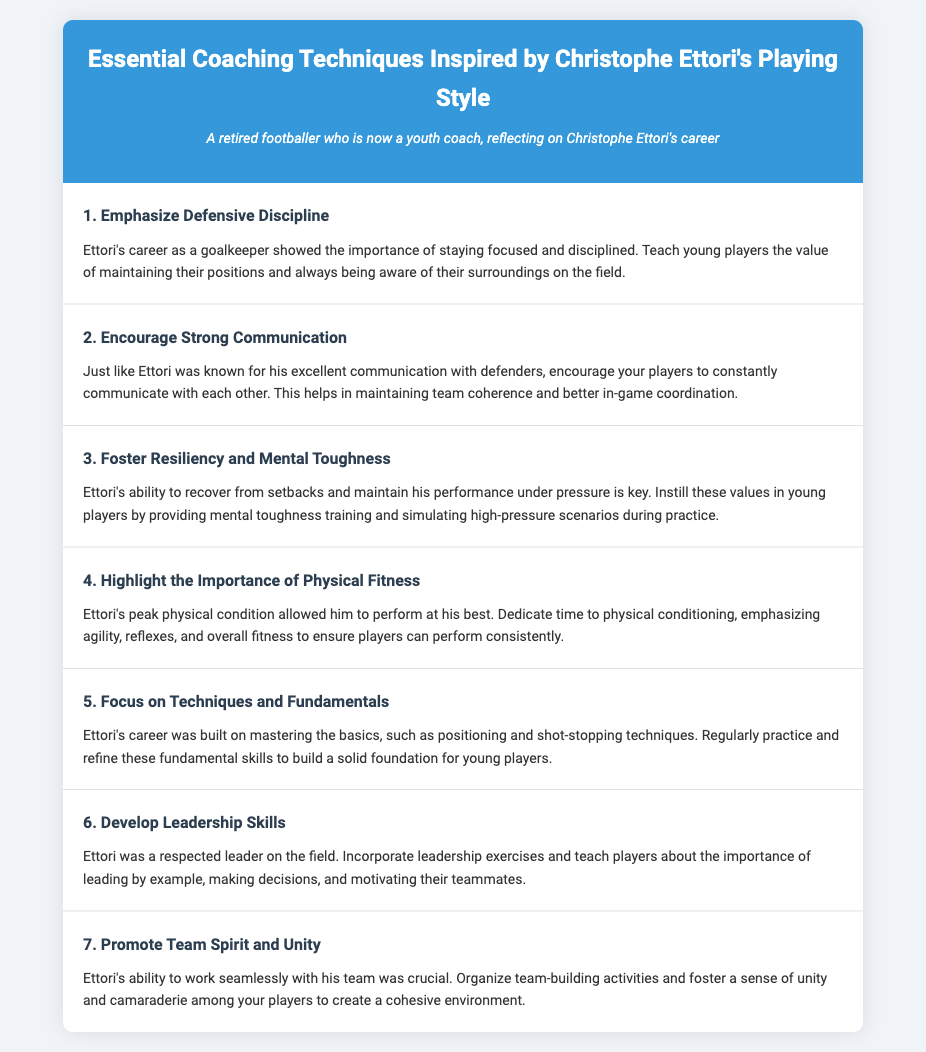what is the title of the document? The title is found at the top of the document in the header section, which states the subject of the coaching techniques.
Answer: Essential Coaching Techniques Inspired by Christophe Ettori how many coaching techniques are listed? The number of techniques can be counted directly from the list in the document.
Answer: 7 what technique highlights the need for physical conditioning? This information can be retrieved from the specific title of the technique related to fitness mentioned in the document.
Answer: Highlight the Importance of Physical Fitness who was known for excellent communication with defenders? The document mentions a specific individual recognized for this trait, which is highlighted in the techniques.
Answer: Ettori what is emphasized in the third technique? This can be found in the description of the third technique discussing mental fortitude.
Answer: Resiliency and Mental Toughness which technique focuses on teamwork? This information pertains to the title of the technique that mentions unity among players.
Answer: Promote Team Spirit and Unity what element does the sixth technique incorporate? This question refers to a specific action described in the document regarding player skill development.
Answer: Leadership Skills 